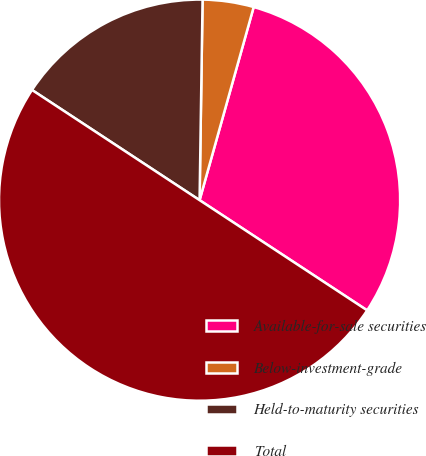<chart> <loc_0><loc_0><loc_500><loc_500><pie_chart><fcel>Available-for-sale securities<fcel>Below-investment-grade<fcel>Held-to-maturity securities<fcel>Total<nl><fcel>29.91%<fcel>4.11%<fcel>15.98%<fcel>50.0%<nl></chart> 